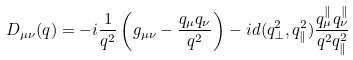<formula> <loc_0><loc_0><loc_500><loc_500>D _ { \mu \nu } ( q ) = - i \frac { 1 } { q ^ { 2 } } \left ( g _ { \mu \nu } - \frac { q _ { \mu } q _ { \nu } } { q ^ { 2 } } \right ) - i d ( q _ { \perp } ^ { 2 } , q _ { \| } ^ { 2 } ) \frac { q _ { \mu } ^ { \| } q _ { \nu } ^ { \| } } { q ^ { 2 } q _ { \| } ^ { 2 } }</formula> 